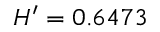Convert formula to latex. <formula><loc_0><loc_0><loc_500><loc_500>H ^ { \prime } = 0 . 6 4 7 3</formula> 